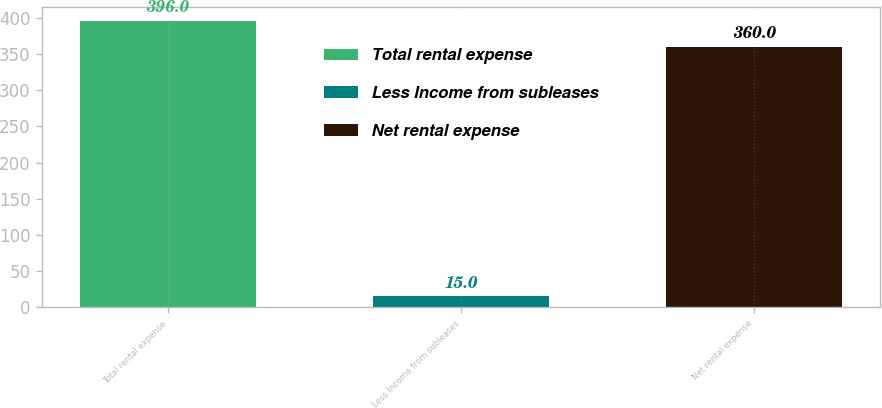<chart> <loc_0><loc_0><loc_500><loc_500><bar_chart><fcel>Total rental expense<fcel>Less Income from subleases<fcel>Net rental expense<nl><fcel>396<fcel>15<fcel>360<nl></chart> 